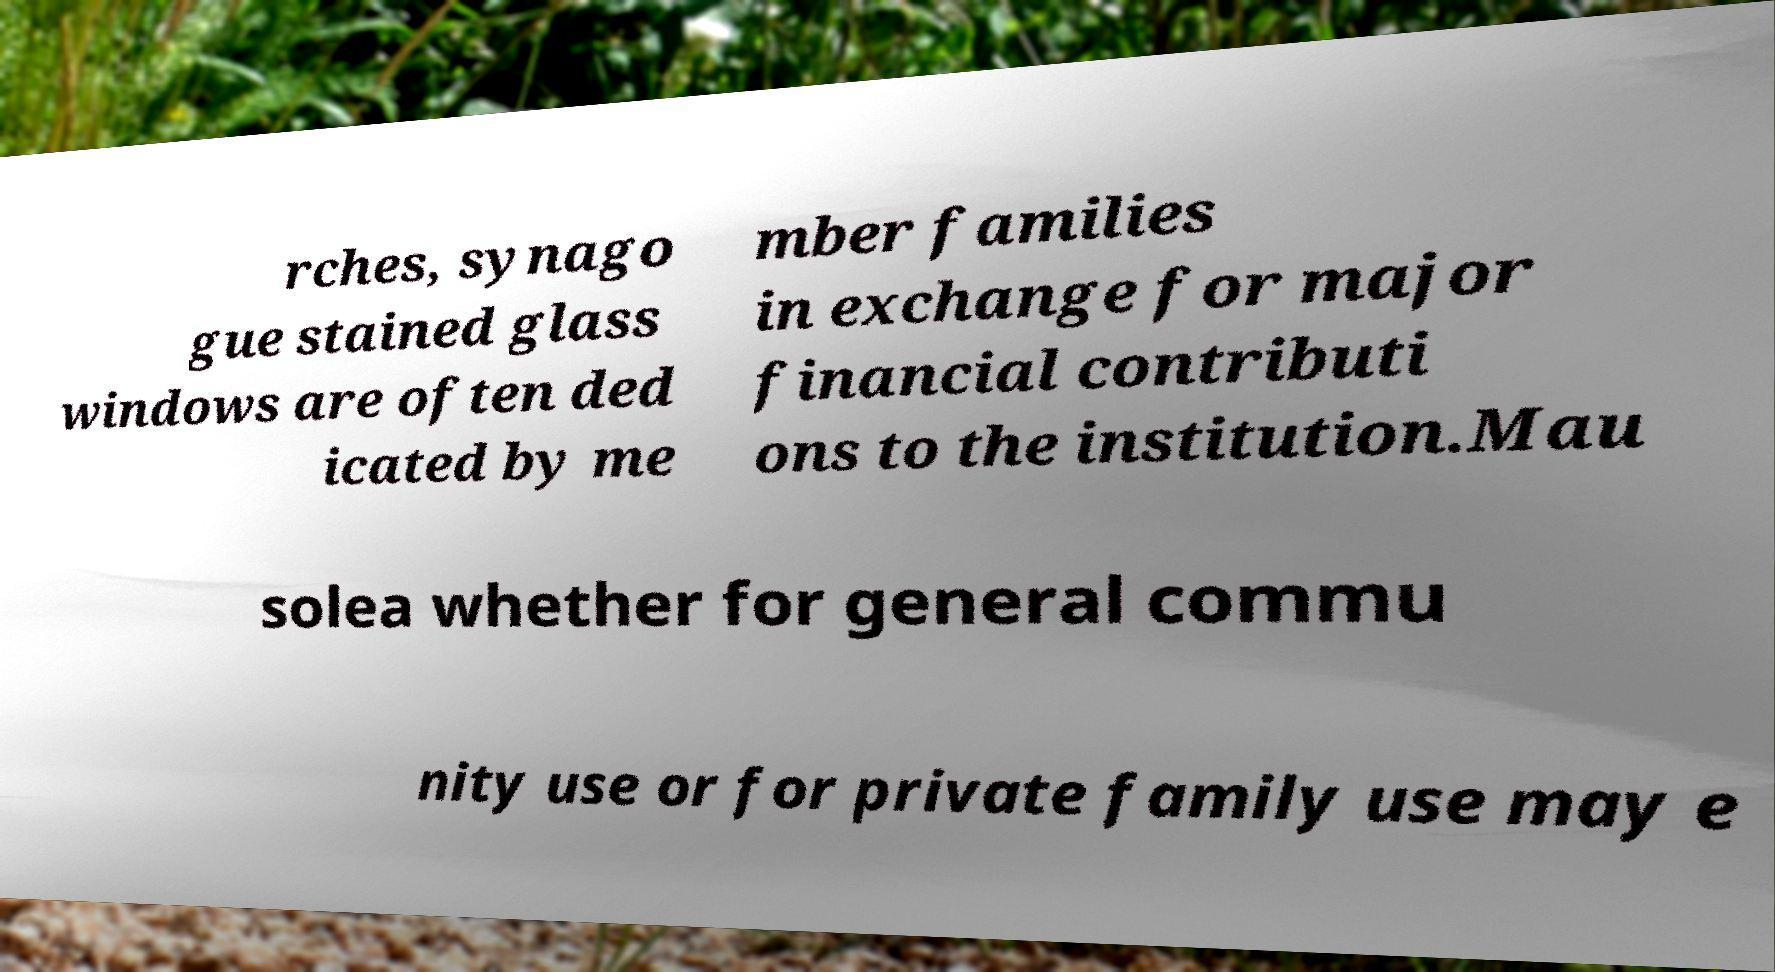Please identify and transcribe the text found in this image. rches, synago gue stained glass windows are often ded icated by me mber families in exchange for major financial contributi ons to the institution.Mau solea whether for general commu nity use or for private family use may e 